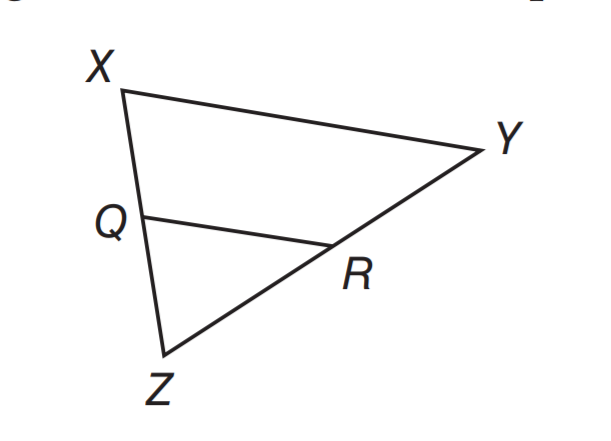Answer the mathemtical geometry problem and directly provide the correct option letter.
Question: If Q R \parallel X Y, X Q = 15, Q Z = 12, and Y R = 20, what is the length of R Z.
Choices: A: 15 B: 16 C: 18 D: 24 B 